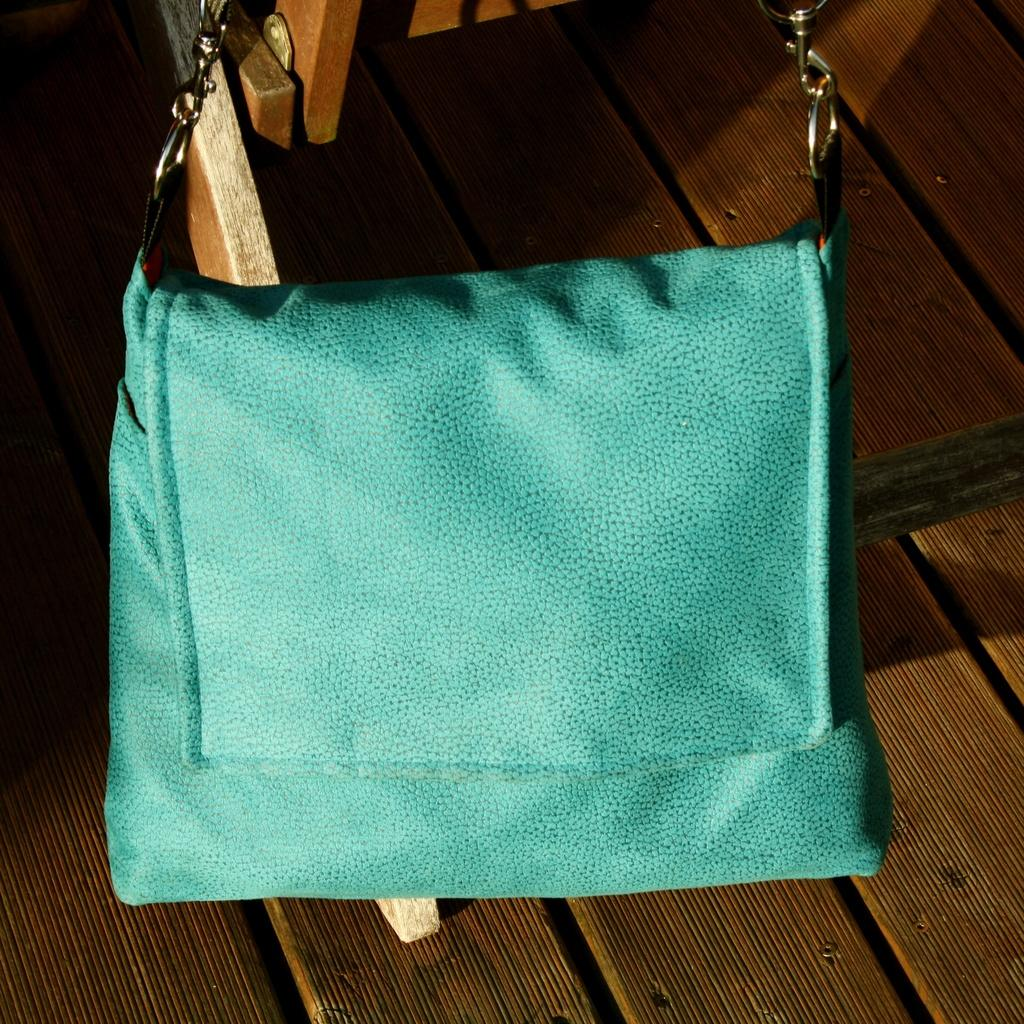What color is the handbag in the image? The handbag in the image is blue. How is the handbag connected to another object? The handbag is attached to an object. What type of competition is taking place on the farm in the image? There is no farm or competition present in the image; it only features a blue handbag attached to an object. 